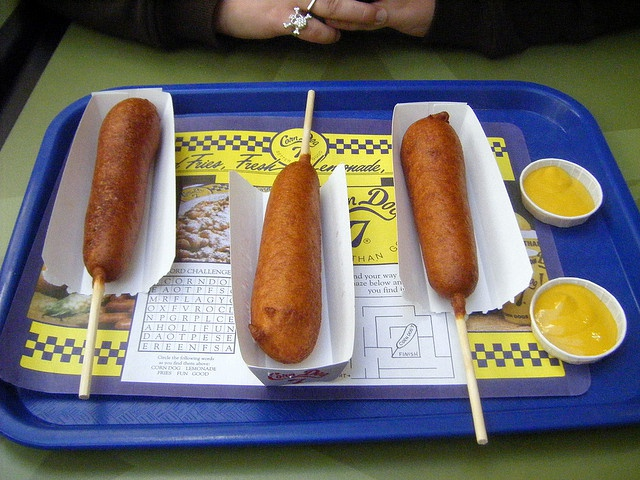Describe the objects in this image and their specific colors. I can see dining table in lightgray, darkgreen, black, navy, and darkgray tones, people in darkgreen, black, gray, and maroon tones, hot dog in darkgreen, brown, orange, and maroon tones, hot dog in darkgreen, maroon, and brown tones, and hot dog in darkgreen, brown, and maroon tones in this image. 